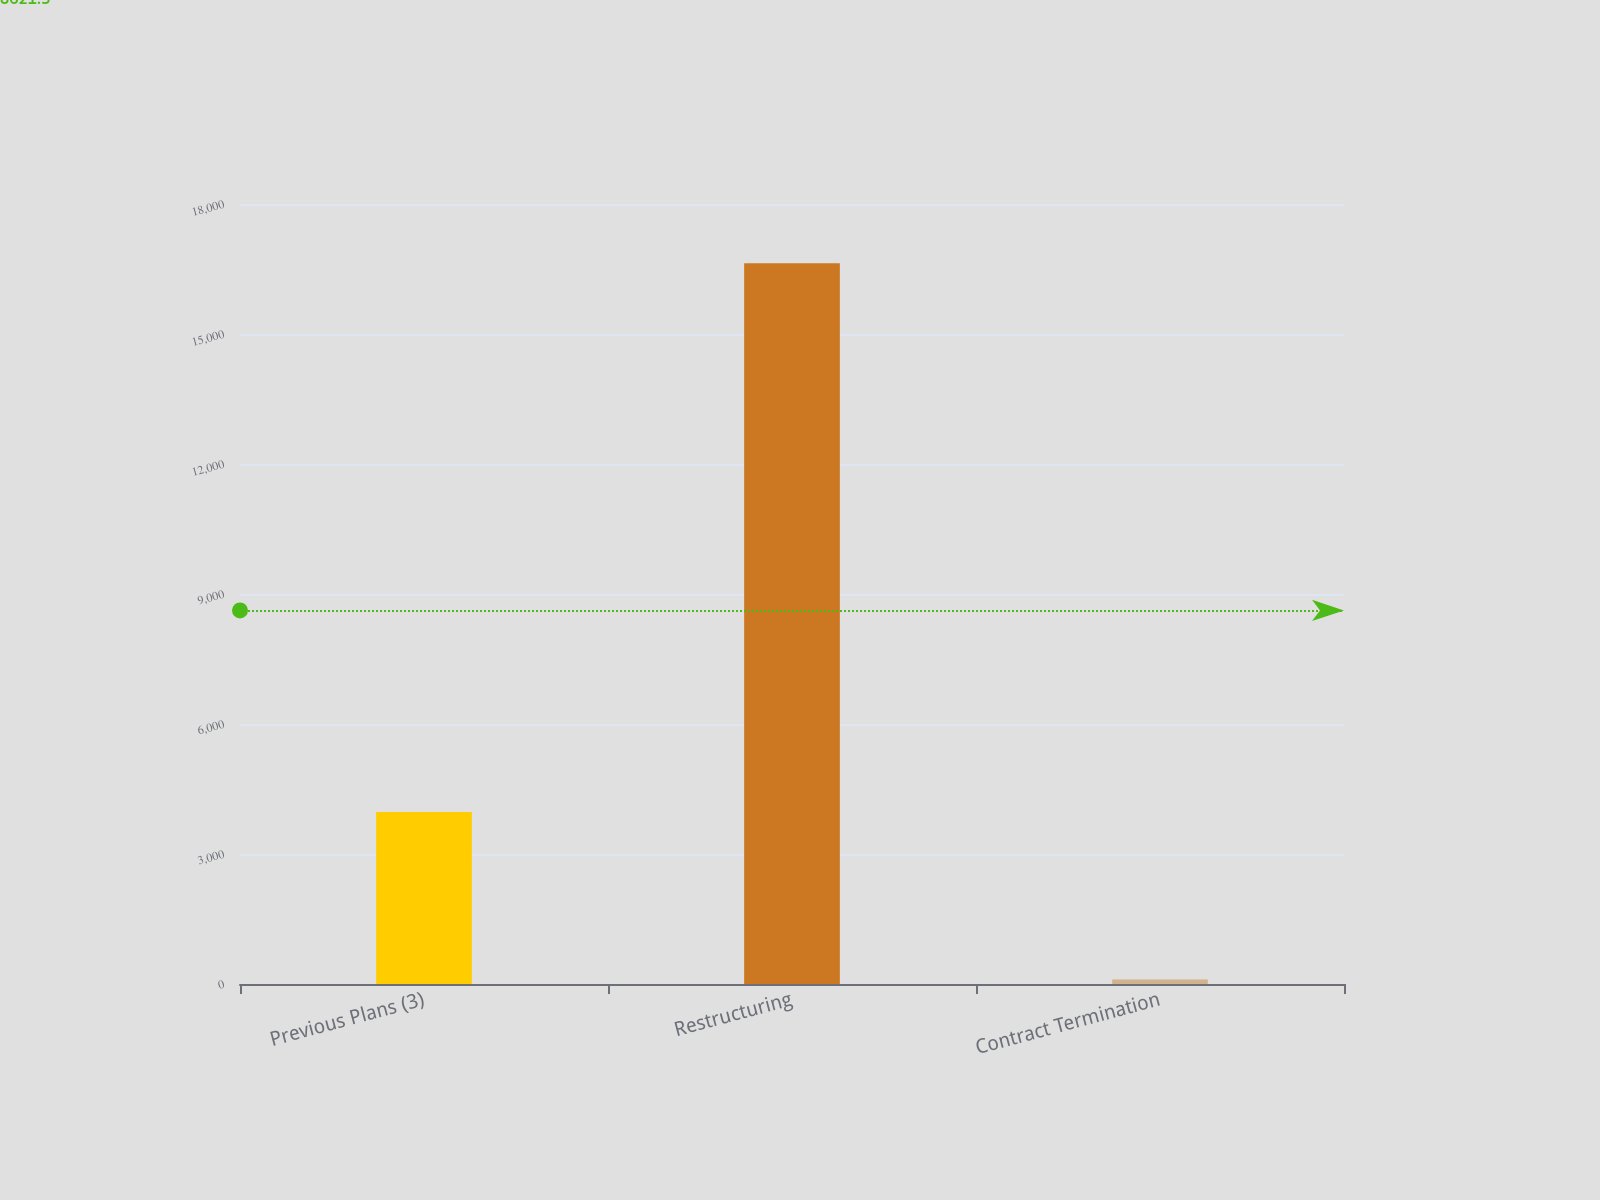<chart> <loc_0><loc_0><loc_500><loc_500><bar_chart><fcel>Previous Plans (3)<fcel>Restructuring<fcel>Contract Termination<nl><fcel>3971<fcel>16630<fcel>103<nl></chart> 